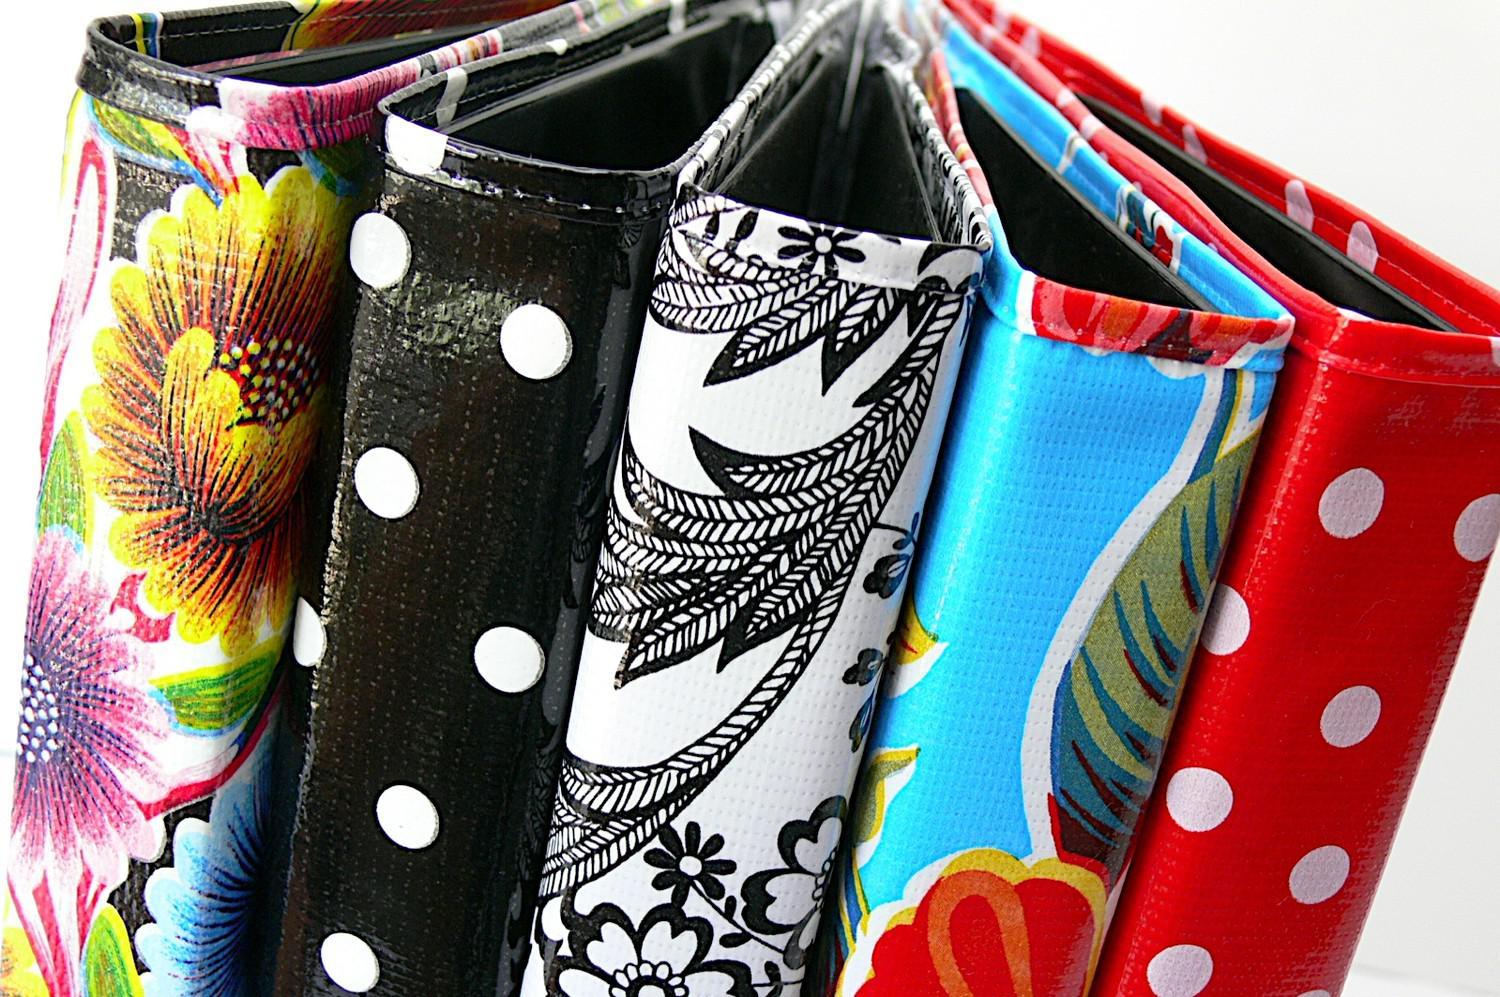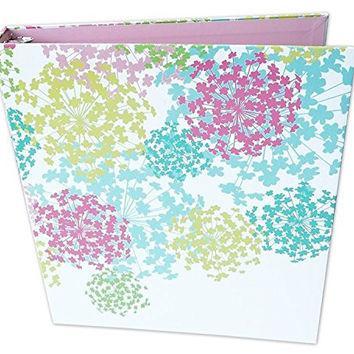The first image is the image on the left, the second image is the image on the right. Analyze the images presented: Is the assertion "There is a single floral binder in the image on the right." valid? Answer yes or no. Yes. The first image is the image on the left, the second image is the image on the right. Considering the images on both sides, is "One image shows exactly five binders displayed side-by-side." valid? Answer yes or no. Yes. 